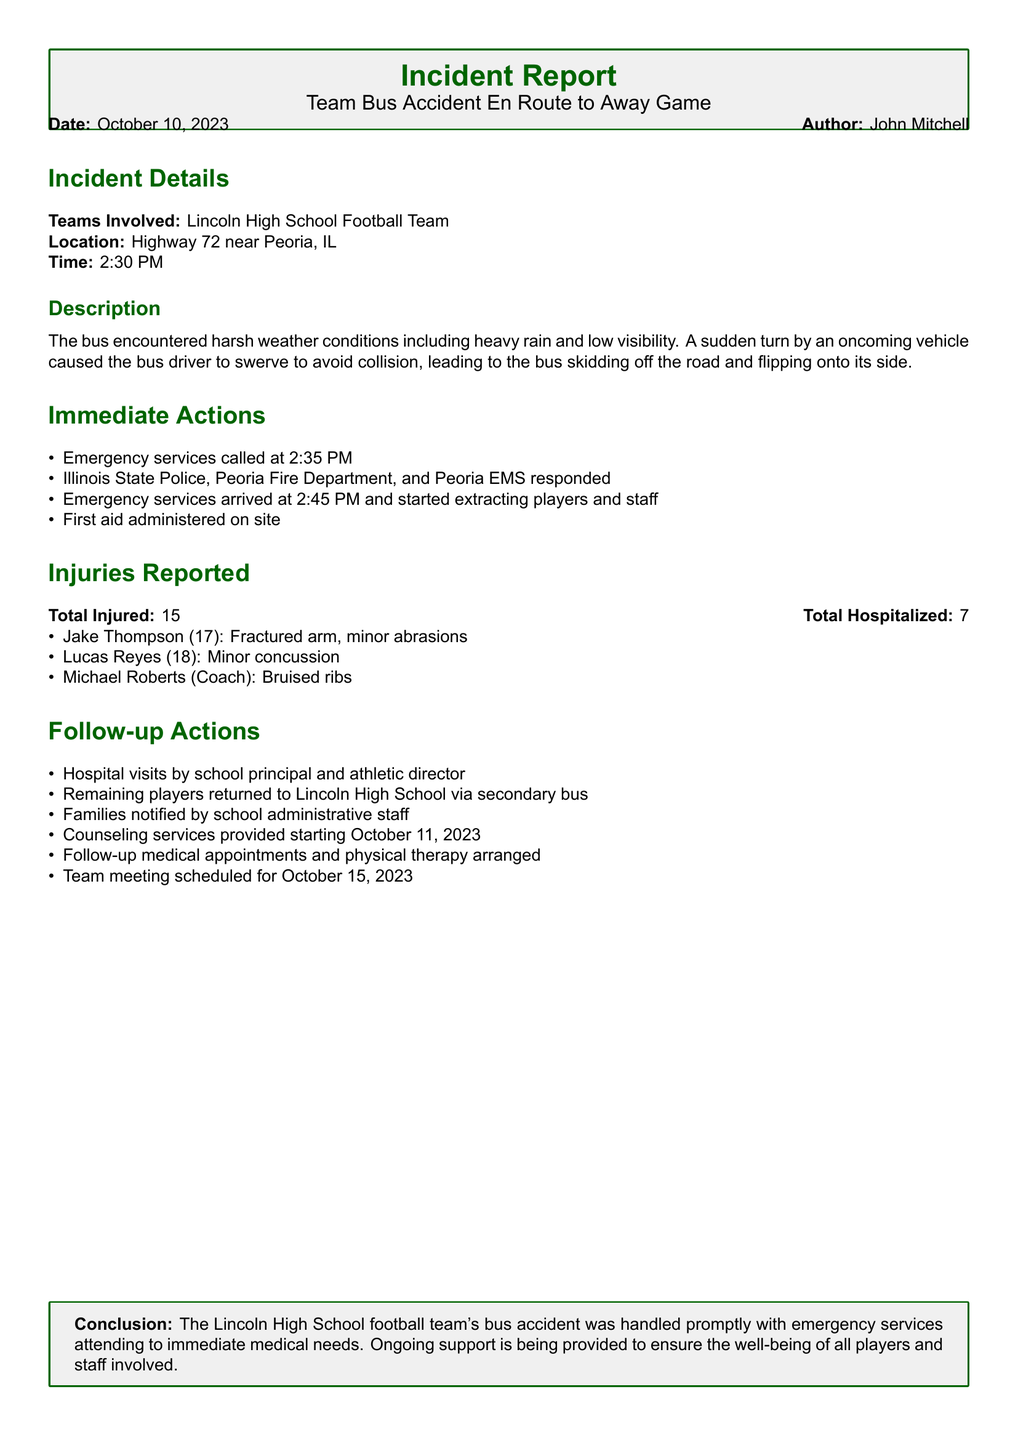What is the date of the incident? The date of the incident is stated clearly in the document as October 10, 2023.
Answer: October 10, 2023 What time did the accident occur? The document specifies the time of the accident as 2:30 PM.
Answer: 2:30 PM How many players were hospitalized? The total number of hospitalized individuals is given as 7 in the injuries report section.
Answer: 7 Who was injured with a fractured arm? The document lists Jake Thompson as the player with a fractured arm.
Answer: Jake Thompson What was the response time of emergency services? The emergency services called at 2:35 PM and arrived at 2:45 PM, indicating a response time of 10 minutes.
Answer: 10 minutes What follow-up action was scheduled for October 15, 2023? The document mentions a team meeting was scheduled for October 15, 2023.
Answer: Team meeting What type of injuries did Lucas Reyes sustain? Lucas Reyes is reported to have sustained a minor concussion.
Answer: Minor concussion Which organizations responded to the incident? The document lists Illinois State Police, Peoria Fire Department, and Peoria EMS as the responders.
Answer: Illinois State Police, Peoria Fire Department, Peoria EMS How many total injuries were reported? The total number of injured individuals is reported as 15.
Answer: 15 